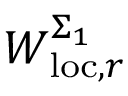<formula> <loc_0><loc_0><loc_500><loc_500>W _ { l o c , r } ^ { \Sigma _ { 1 } }</formula> 